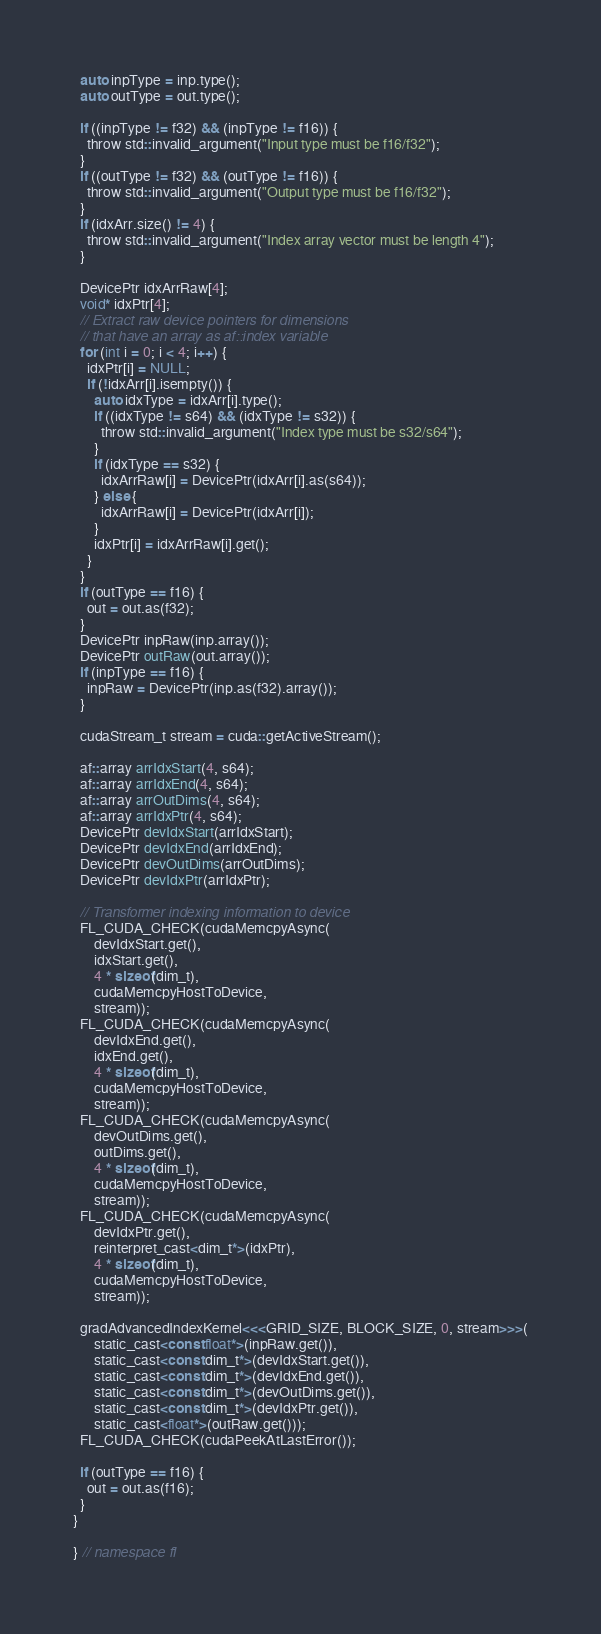Convert code to text. <code><loc_0><loc_0><loc_500><loc_500><_Cuda_>  auto inpType = inp.type();
  auto outType = out.type();

  if ((inpType != f32) && (inpType != f16)) {
    throw std::invalid_argument("Input type must be f16/f32");
  }
  if ((outType != f32) && (outType != f16)) {
    throw std::invalid_argument("Output type must be f16/f32");
  }
  if (idxArr.size() != 4) {
    throw std::invalid_argument("Index array vector must be length 4");
  }

  DevicePtr idxArrRaw[4];
  void* idxPtr[4];
  // Extract raw device pointers for dimensions
  // that have an array as af::index variable
  for (int i = 0; i < 4; i++) {
    idxPtr[i] = NULL;
    if (!idxArr[i].isempty()) {
      auto idxType = idxArr[i].type();
      if ((idxType != s64) && (idxType != s32)) {
        throw std::invalid_argument("Index type must be s32/s64");
      }
      if (idxType == s32) {
        idxArrRaw[i] = DevicePtr(idxArr[i].as(s64));
      } else {
        idxArrRaw[i] = DevicePtr(idxArr[i]);
      }
      idxPtr[i] = idxArrRaw[i].get();
    }
  }
  if (outType == f16) {
    out = out.as(f32);
  }
  DevicePtr inpRaw(inp.array());
  DevicePtr outRaw(out.array());
  if (inpType == f16) {
    inpRaw = DevicePtr(inp.as(f32).array());
  }

  cudaStream_t stream = cuda::getActiveStream();

  af::array arrIdxStart(4, s64);
  af::array arrIdxEnd(4, s64);
  af::array arrOutDims(4, s64);
  af::array arrIdxPtr(4, s64);
  DevicePtr devIdxStart(arrIdxStart);
  DevicePtr devIdxEnd(arrIdxEnd);
  DevicePtr devOutDims(arrOutDims);
  DevicePtr devIdxPtr(arrIdxPtr);

  // Transformer indexing information to device
  FL_CUDA_CHECK(cudaMemcpyAsync(
      devIdxStart.get(),
      idxStart.get(),
      4 * sizeof(dim_t),
      cudaMemcpyHostToDevice,
      stream));
  FL_CUDA_CHECK(cudaMemcpyAsync(
      devIdxEnd.get(),
      idxEnd.get(),
      4 * sizeof(dim_t),
      cudaMemcpyHostToDevice,
      stream));
  FL_CUDA_CHECK(cudaMemcpyAsync(
      devOutDims.get(),
      outDims.get(),
      4 * sizeof(dim_t),
      cudaMemcpyHostToDevice,
      stream));
  FL_CUDA_CHECK(cudaMemcpyAsync(
      devIdxPtr.get(),
      reinterpret_cast<dim_t*>(idxPtr),
      4 * sizeof(dim_t),
      cudaMemcpyHostToDevice,
      stream));

  gradAdvancedIndexKernel<<<GRID_SIZE, BLOCK_SIZE, 0, stream>>>(
      static_cast<const float*>(inpRaw.get()),
      static_cast<const dim_t*>(devIdxStart.get()),
      static_cast<const dim_t*>(devIdxEnd.get()),
      static_cast<const dim_t*>(devOutDims.get()),
      static_cast<const dim_t*>(devIdxPtr.get()),
      static_cast<float*>(outRaw.get()));
  FL_CUDA_CHECK(cudaPeekAtLastError());

  if (outType == f16) {
    out = out.as(f16);
  }
}

} // namespace fl
</code> 